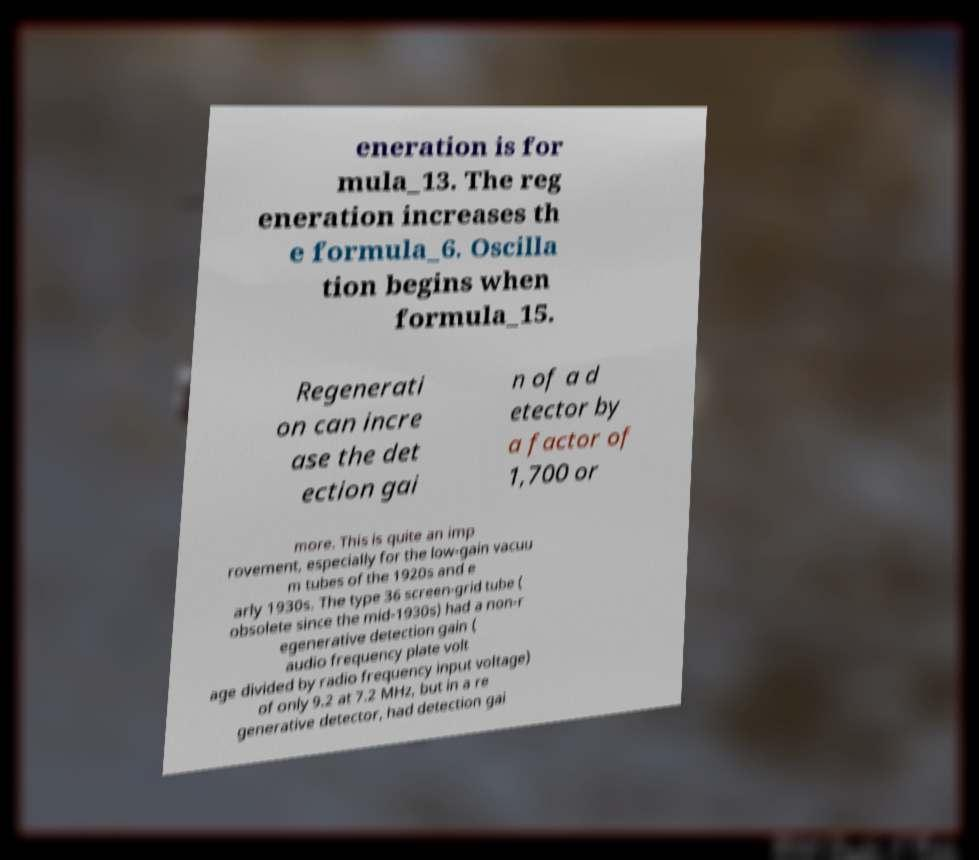What messages or text are displayed in this image? I need them in a readable, typed format. eneration is for mula_13. The reg eneration increases th e formula_6. Oscilla tion begins when formula_15. Regenerati on can incre ase the det ection gai n of a d etector by a factor of 1,700 or more. This is quite an imp rovement, especially for the low-gain vacuu m tubes of the 1920s and e arly 1930s. The type 36 screen-grid tube ( obsolete since the mid-1930s) had a non-r egenerative detection gain ( audio frequency plate volt age divided by radio frequency input voltage) of only 9.2 at 7.2 MHz, but in a re generative detector, had detection gai 